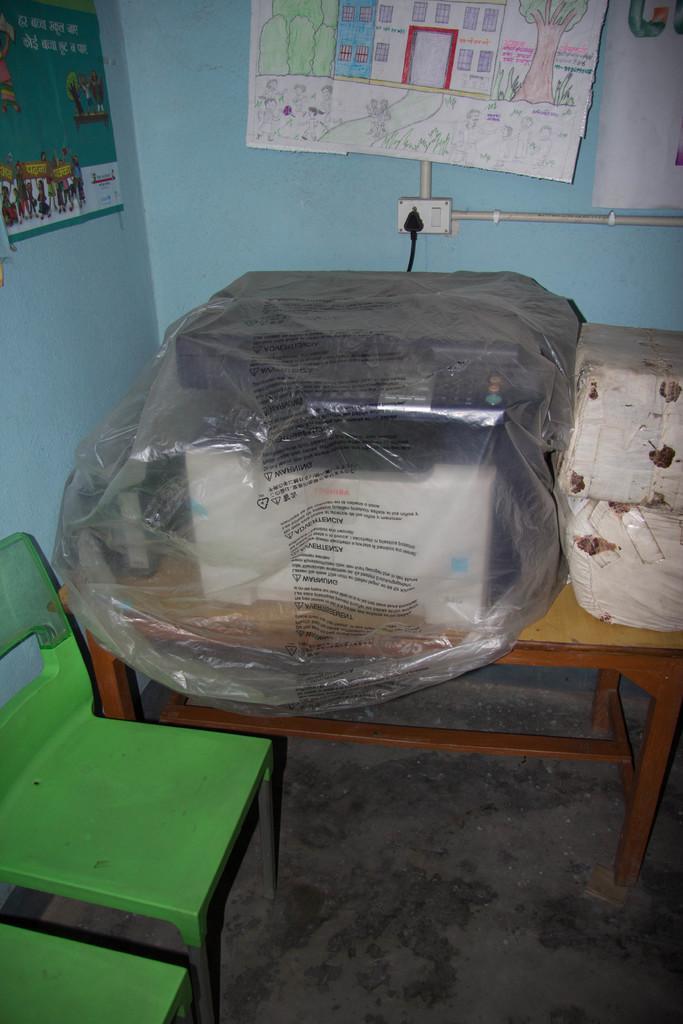Can you describe this image briefly? As we can see in the image there is a wall, sheet, a table. On table there is a box and television, switch board and chairs. 